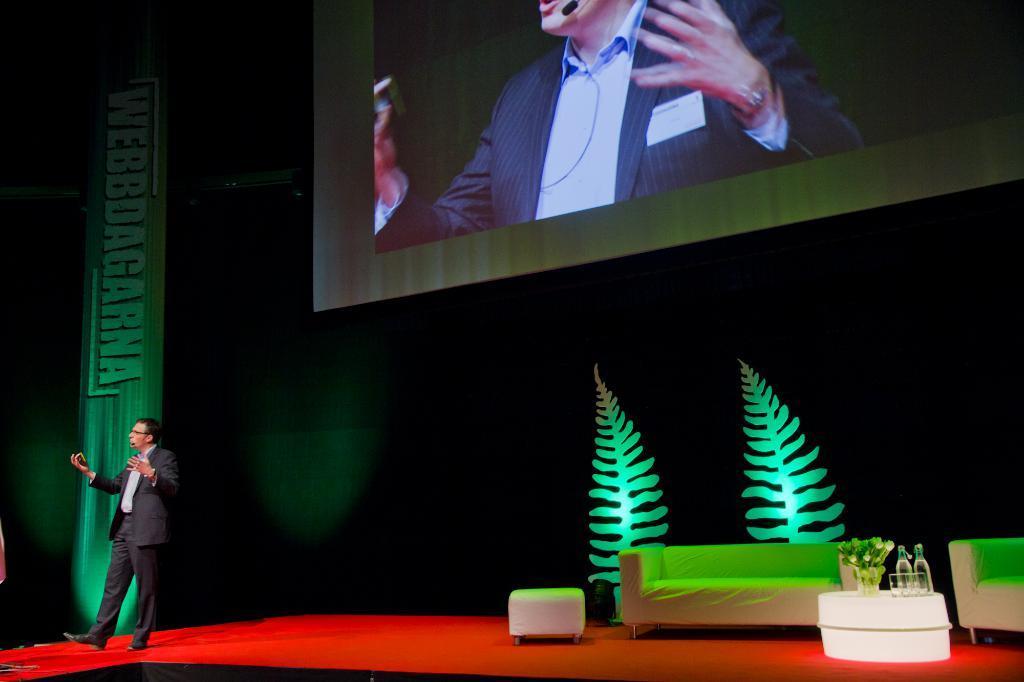In one or two sentences, can you explain what this image depicts? In this image there is a person speaking on the stage, on the stage there are sofas and a table, on the table there are some objects, in the background of the image there is a screen and a banner. 